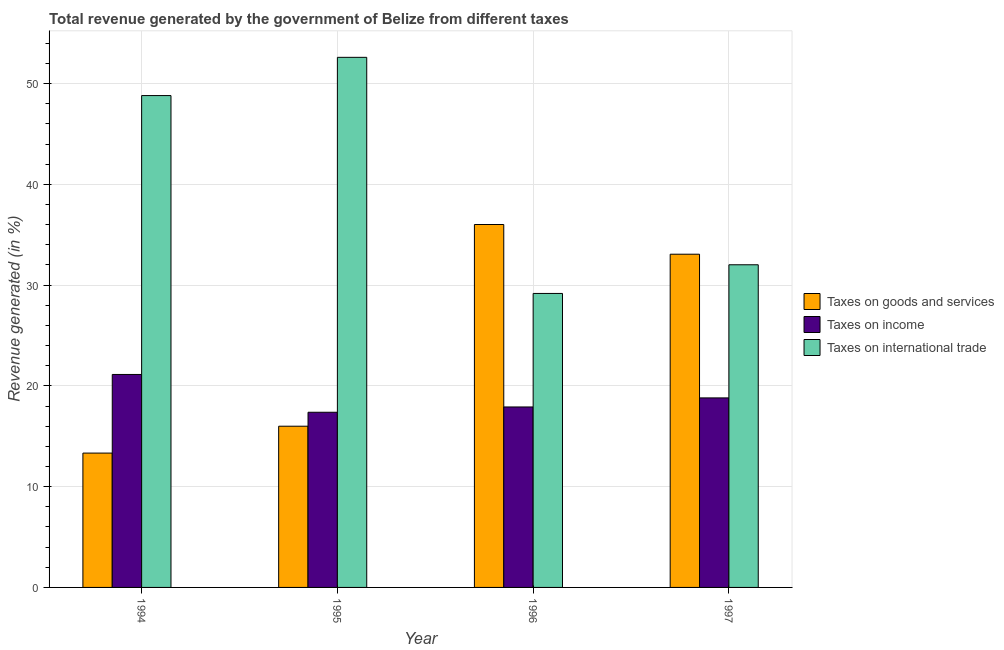How many different coloured bars are there?
Keep it short and to the point. 3. How many groups of bars are there?
Make the answer very short. 4. How many bars are there on the 3rd tick from the left?
Make the answer very short. 3. What is the percentage of revenue generated by tax on international trade in 1997?
Provide a short and direct response. 32.02. Across all years, what is the maximum percentage of revenue generated by taxes on goods and services?
Make the answer very short. 36.01. Across all years, what is the minimum percentage of revenue generated by taxes on goods and services?
Provide a succinct answer. 13.33. In which year was the percentage of revenue generated by taxes on income minimum?
Your response must be concise. 1995. What is the total percentage of revenue generated by taxes on income in the graph?
Give a very brief answer. 75.23. What is the difference between the percentage of revenue generated by taxes on goods and services in 1994 and that in 1997?
Keep it short and to the point. -19.73. What is the difference between the percentage of revenue generated by taxes on income in 1996 and the percentage of revenue generated by taxes on goods and services in 1997?
Provide a succinct answer. -0.9. What is the average percentage of revenue generated by taxes on goods and services per year?
Make the answer very short. 24.6. In the year 1997, what is the difference between the percentage of revenue generated by tax on international trade and percentage of revenue generated by taxes on income?
Make the answer very short. 0. What is the ratio of the percentage of revenue generated by taxes on income in 1995 to that in 1997?
Provide a short and direct response. 0.92. What is the difference between the highest and the second highest percentage of revenue generated by tax on international trade?
Your response must be concise. 3.79. What is the difference between the highest and the lowest percentage of revenue generated by taxes on goods and services?
Your answer should be very brief. 22.68. In how many years, is the percentage of revenue generated by tax on international trade greater than the average percentage of revenue generated by tax on international trade taken over all years?
Give a very brief answer. 2. Is the sum of the percentage of revenue generated by taxes on goods and services in 1994 and 1996 greater than the maximum percentage of revenue generated by taxes on income across all years?
Ensure brevity in your answer.  Yes. What does the 2nd bar from the left in 1994 represents?
Your answer should be compact. Taxes on income. What does the 3rd bar from the right in 1996 represents?
Keep it short and to the point. Taxes on goods and services. Are all the bars in the graph horizontal?
Provide a short and direct response. No. What is the difference between two consecutive major ticks on the Y-axis?
Your response must be concise. 10. Where does the legend appear in the graph?
Your response must be concise. Center right. How many legend labels are there?
Your response must be concise. 3. How are the legend labels stacked?
Your response must be concise. Vertical. What is the title of the graph?
Ensure brevity in your answer.  Total revenue generated by the government of Belize from different taxes. What is the label or title of the X-axis?
Ensure brevity in your answer.  Year. What is the label or title of the Y-axis?
Offer a terse response. Revenue generated (in %). What is the Revenue generated (in %) in Taxes on goods and services in 1994?
Offer a very short reply. 13.33. What is the Revenue generated (in %) of Taxes on income in 1994?
Offer a very short reply. 21.13. What is the Revenue generated (in %) in Taxes on international trade in 1994?
Ensure brevity in your answer.  48.81. What is the Revenue generated (in %) of Taxes on goods and services in 1995?
Your answer should be compact. 16. What is the Revenue generated (in %) in Taxes on income in 1995?
Provide a short and direct response. 17.38. What is the Revenue generated (in %) in Taxes on international trade in 1995?
Your response must be concise. 52.6. What is the Revenue generated (in %) in Taxes on goods and services in 1996?
Offer a very short reply. 36.01. What is the Revenue generated (in %) in Taxes on income in 1996?
Your answer should be compact. 17.91. What is the Revenue generated (in %) in Taxes on international trade in 1996?
Make the answer very short. 29.17. What is the Revenue generated (in %) of Taxes on goods and services in 1997?
Provide a succinct answer. 33.07. What is the Revenue generated (in %) of Taxes on income in 1997?
Offer a very short reply. 18.81. What is the Revenue generated (in %) in Taxes on international trade in 1997?
Your answer should be compact. 32.02. Across all years, what is the maximum Revenue generated (in %) of Taxes on goods and services?
Offer a terse response. 36.01. Across all years, what is the maximum Revenue generated (in %) of Taxes on income?
Keep it short and to the point. 21.13. Across all years, what is the maximum Revenue generated (in %) of Taxes on international trade?
Your answer should be very brief. 52.6. Across all years, what is the minimum Revenue generated (in %) in Taxes on goods and services?
Give a very brief answer. 13.33. Across all years, what is the minimum Revenue generated (in %) in Taxes on income?
Your answer should be very brief. 17.38. Across all years, what is the minimum Revenue generated (in %) of Taxes on international trade?
Keep it short and to the point. 29.17. What is the total Revenue generated (in %) in Taxes on goods and services in the graph?
Provide a short and direct response. 98.41. What is the total Revenue generated (in %) of Taxes on income in the graph?
Offer a terse response. 75.23. What is the total Revenue generated (in %) in Taxes on international trade in the graph?
Offer a terse response. 162.6. What is the difference between the Revenue generated (in %) in Taxes on goods and services in 1994 and that in 1995?
Your response must be concise. -2.67. What is the difference between the Revenue generated (in %) of Taxes on income in 1994 and that in 1995?
Your answer should be compact. 3.75. What is the difference between the Revenue generated (in %) of Taxes on international trade in 1994 and that in 1995?
Give a very brief answer. -3.79. What is the difference between the Revenue generated (in %) in Taxes on goods and services in 1994 and that in 1996?
Keep it short and to the point. -22.68. What is the difference between the Revenue generated (in %) of Taxes on income in 1994 and that in 1996?
Make the answer very short. 3.23. What is the difference between the Revenue generated (in %) of Taxes on international trade in 1994 and that in 1996?
Give a very brief answer. 19.64. What is the difference between the Revenue generated (in %) of Taxes on goods and services in 1994 and that in 1997?
Make the answer very short. -19.73. What is the difference between the Revenue generated (in %) in Taxes on income in 1994 and that in 1997?
Provide a short and direct response. 2.33. What is the difference between the Revenue generated (in %) in Taxes on international trade in 1994 and that in 1997?
Make the answer very short. 16.79. What is the difference between the Revenue generated (in %) of Taxes on goods and services in 1995 and that in 1996?
Your answer should be very brief. -20.02. What is the difference between the Revenue generated (in %) in Taxes on income in 1995 and that in 1996?
Your answer should be very brief. -0.53. What is the difference between the Revenue generated (in %) in Taxes on international trade in 1995 and that in 1996?
Provide a succinct answer. 23.43. What is the difference between the Revenue generated (in %) in Taxes on goods and services in 1995 and that in 1997?
Your response must be concise. -17.07. What is the difference between the Revenue generated (in %) of Taxes on income in 1995 and that in 1997?
Your answer should be compact. -1.43. What is the difference between the Revenue generated (in %) in Taxes on international trade in 1995 and that in 1997?
Offer a very short reply. 20.59. What is the difference between the Revenue generated (in %) in Taxes on goods and services in 1996 and that in 1997?
Make the answer very short. 2.95. What is the difference between the Revenue generated (in %) in Taxes on income in 1996 and that in 1997?
Make the answer very short. -0.9. What is the difference between the Revenue generated (in %) in Taxes on international trade in 1996 and that in 1997?
Ensure brevity in your answer.  -2.85. What is the difference between the Revenue generated (in %) in Taxes on goods and services in 1994 and the Revenue generated (in %) in Taxes on income in 1995?
Ensure brevity in your answer.  -4.05. What is the difference between the Revenue generated (in %) in Taxes on goods and services in 1994 and the Revenue generated (in %) in Taxes on international trade in 1995?
Your response must be concise. -39.27. What is the difference between the Revenue generated (in %) in Taxes on income in 1994 and the Revenue generated (in %) in Taxes on international trade in 1995?
Make the answer very short. -31.47. What is the difference between the Revenue generated (in %) of Taxes on goods and services in 1994 and the Revenue generated (in %) of Taxes on income in 1996?
Keep it short and to the point. -4.58. What is the difference between the Revenue generated (in %) in Taxes on goods and services in 1994 and the Revenue generated (in %) in Taxes on international trade in 1996?
Keep it short and to the point. -15.84. What is the difference between the Revenue generated (in %) of Taxes on income in 1994 and the Revenue generated (in %) of Taxes on international trade in 1996?
Keep it short and to the point. -8.04. What is the difference between the Revenue generated (in %) in Taxes on goods and services in 1994 and the Revenue generated (in %) in Taxes on income in 1997?
Provide a short and direct response. -5.48. What is the difference between the Revenue generated (in %) of Taxes on goods and services in 1994 and the Revenue generated (in %) of Taxes on international trade in 1997?
Your response must be concise. -18.69. What is the difference between the Revenue generated (in %) in Taxes on income in 1994 and the Revenue generated (in %) in Taxes on international trade in 1997?
Give a very brief answer. -10.88. What is the difference between the Revenue generated (in %) of Taxes on goods and services in 1995 and the Revenue generated (in %) of Taxes on income in 1996?
Offer a very short reply. -1.91. What is the difference between the Revenue generated (in %) of Taxes on goods and services in 1995 and the Revenue generated (in %) of Taxes on international trade in 1996?
Your answer should be very brief. -13.17. What is the difference between the Revenue generated (in %) of Taxes on income in 1995 and the Revenue generated (in %) of Taxes on international trade in 1996?
Offer a terse response. -11.79. What is the difference between the Revenue generated (in %) of Taxes on goods and services in 1995 and the Revenue generated (in %) of Taxes on income in 1997?
Give a very brief answer. -2.81. What is the difference between the Revenue generated (in %) of Taxes on goods and services in 1995 and the Revenue generated (in %) of Taxes on international trade in 1997?
Keep it short and to the point. -16.02. What is the difference between the Revenue generated (in %) in Taxes on income in 1995 and the Revenue generated (in %) in Taxes on international trade in 1997?
Make the answer very short. -14.64. What is the difference between the Revenue generated (in %) in Taxes on goods and services in 1996 and the Revenue generated (in %) in Taxes on income in 1997?
Your answer should be compact. 17.21. What is the difference between the Revenue generated (in %) of Taxes on goods and services in 1996 and the Revenue generated (in %) of Taxes on international trade in 1997?
Ensure brevity in your answer.  4. What is the difference between the Revenue generated (in %) of Taxes on income in 1996 and the Revenue generated (in %) of Taxes on international trade in 1997?
Your answer should be compact. -14.11. What is the average Revenue generated (in %) in Taxes on goods and services per year?
Ensure brevity in your answer.  24.6. What is the average Revenue generated (in %) in Taxes on income per year?
Make the answer very short. 18.81. What is the average Revenue generated (in %) in Taxes on international trade per year?
Make the answer very short. 40.65. In the year 1994, what is the difference between the Revenue generated (in %) of Taxes on goods and services and Revenue generated (in %) of Taxes on income?
Your response must be concise. -7.8. In the year 1994, what is the difference between the Revenue generated (in %) of Taxes on goods and services and Revenue generated (in %) of Taxes on international trade?
Keep it short and to the point. -35.48. In the year 1994, what is the difference between the Revenue generated (in %) of Taxes on income and Revenue generated (in %) of Taxes on international trade?
Your answer should be very brief. -27.67. In the year 1995, what is the difference between the Revenue generated (in %) in Taxes on goods and services and Revenue generated (in %) in Taxes on income?
Your answer should be very brief. -1.38. In the year 1995, what is the difference between the Revenue generated (in %) in Taxes on goods and services and Revenue generated (in %) in Taxes on international trade?
Ensure brevity in your answer.  -36.61. In the year 1995, what is the difference between the Revenue generated (in %) in Taxes on income and Revenue generated (in %) in Taxes on international trade?
Make the answer very short. -35.22. In the year 1996, what is the difference between the Revenue generated (in %) of Taxes on goods and services and Revenue generated (in %) of Taxes on income?
Provide a succinct answer. 18.11. In the year 1996, what is the difference between the Revenue generated (in %) of Taxes on goods and services and Revenue generated (in %) of Taxes on international trade?
Offer a very short reply. 6.84. In the year 1996, what is the difference between the Revenue generated (in %) in Taxes on income and Revenue generated (in %) in Taxes on international trade?
Provide a succinct answer. -11.26. In the year 1997, what is the difference between the Revenue generated (in %) of Taxes on goods and services and Revenue generated (in %) of Taxes on income?
Give a very brief answer. 14.26. In the year 1997, what is the difference between the Revenue generated (in %) of Taxes on goods and services and Revenue generated (in %) of Taxes on international trade?
Your answer should be compact. 1.05. In the year 1997, what is the difference between the Revenue generated (in %) in Taxes on income and Revenue generated (in %) in Taxes on international trade?
Offer a very short reply. -13.21. What is the ratio of the Revenue generated (in %) of Taxes on goods and services in 1994 to that in 1995?
Give a very brief answer. 0.83. What is the ratio of the Revenue generated (in %) in Taxes on income in 1994 to that in 1995?
Keep it short and to the point. 1.22. What is the ratio of the Revenue generated (in %) in Taxes on international trade in 1994 to that in 1995?
Provide a succinct answer. 0.93. What is the ratio of the Revenue generated (in %) in Taxes on goods and services in 1994 to that in 1996?
Your answer should be very brief. 0.37. What is the ratio of the Revenue generated (in %) in Taxes on income in 1994 to that in 1996?
Ensure brevity in your answer.  1.18. What is the ratio of the Revenue generated (in %) of Taxes on international trade in 1994 to that in 1996?
Your response must be concise. 1.67. What is the ratio of the Revenue generated (in %) in Taxes on goods and services in 1994 to that in 1997?
Give a very brief answer. 0.4. What is the ratio of the Revenue generated (in %) in Taxes on income in 1994 to that in 1997?
Provide a succinct answer. 1.12. What is the ratio of the Revenue generated (in %) in Taxes on international trade in 1994 to that in 1997?
Your answer should be compact. 1.52. What is the ratio of the Revenue generated (in %) of Taxes on goods and services in 1995 to that in 1996?
Make the answer very short. 0.44. What is the ratio of the Revenue generated (in %) of Taxes on income in 1995 to that in 1996?
Provide a short and direct response. 0.97. What is the ratio of the Revenue generated (in %) in Taxes on international trade in 1995 to that in 1996?
Your answer should be compact. 1.8. What is the ratio of the Revenue generated (in %) of Taxes on goods and services in 1995 to that in 1997?
Your answer should be compact. 0.48. What is the ratio of the Revenue generated (in %) of Taxes on income in 1995 to that in 1997?
Make the answer very short. 0.92. What is the ratio of the Revenue generated (in %) in Taxes on international trade in 1995 to that in 1997?
Ensure brevity in your answer.  1.64. What is the ratio of the Revenue generated (in %) of Taxes on goods and services in 1996 to that in 1997?
Provide a short and direct response. 1.09. What is the ratio of the Revenue generated (in %) of Taxes on income in 1996 to that in 1997?
Provide a short and direct response. 0.95. What is the ratio of the Revenue generated (in %) in Taxes on international trade in 1996 to that in 1997?
Provide a succinct answer. 0.91. What is the difference between the highest and the second highest Revenue generated (in %) of Taxes on goods and services?
Provide a succinct answer. 2.95. What is the difference between the highest and the second highest Revenue generated (in %) of Taxes on income?
Ensure brevity in your answer.  2.33. What is the difference between the highest and the second highest Revenue generated (in %) of Taxes on international trade?
Offer a very short reply. 3.79. What is the difference between the highest and the lowest Revenue generated (in %) of Taxes on goods and services?
Ensure brevity in your answer.  22.68. What is the difference between the highest and the lowest Revenue generated (in %) of Taxes on income?
Provide a succinct answer. 3.75. What is the difference between the highest and the lowest Revenue generated (in %) in Taxes on international trade?
Your answer should be very brief. 23.43. 